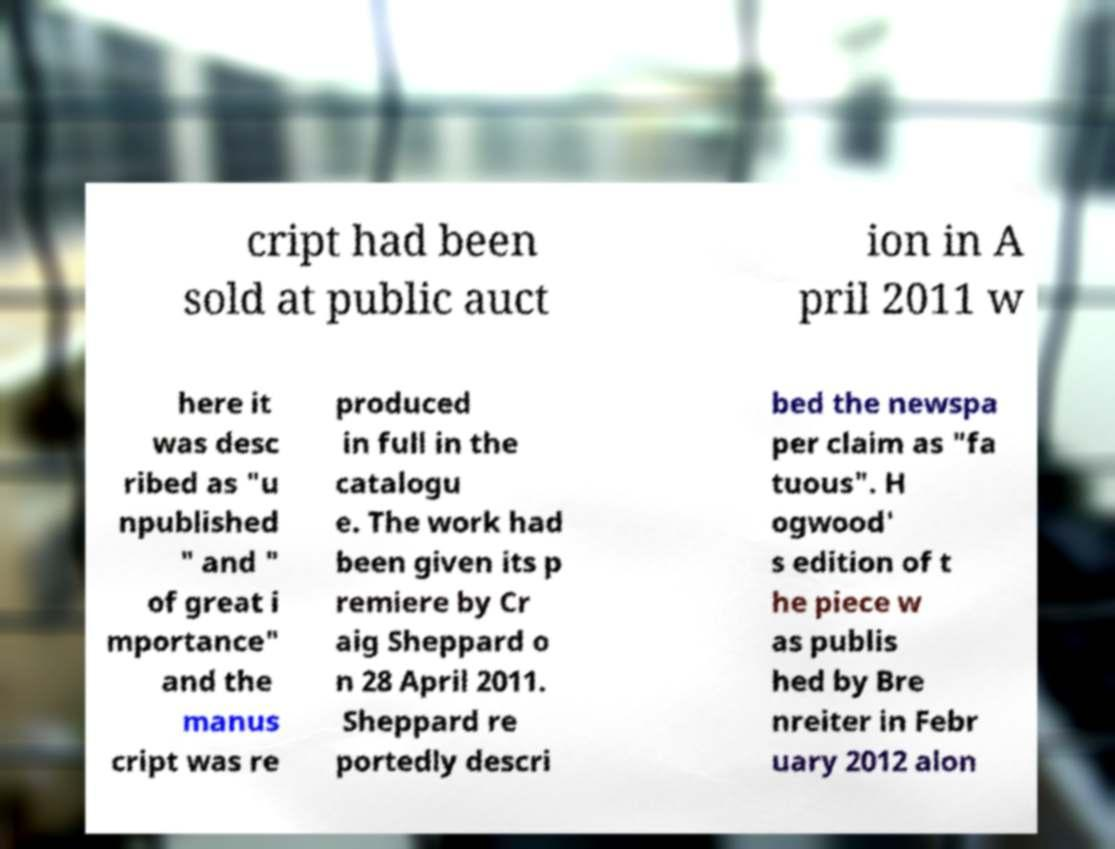Could you extract and type out the text from this image? cript had been sold at public auct ion in A pril 2011 w here it was desc ribed as "u npublished " and " of great i mportance" and the manus cript was re produced in full in the catalogu e. The work had been given its p remiere by Cr aig Sheppard o n 28 April 2011. Sheppard re portedly descri bed the newspa per claim as "fa tuous". H ogwood' s edition of t he piece w as publis hed by Bre nreiter in Febr uary 2012 alon 